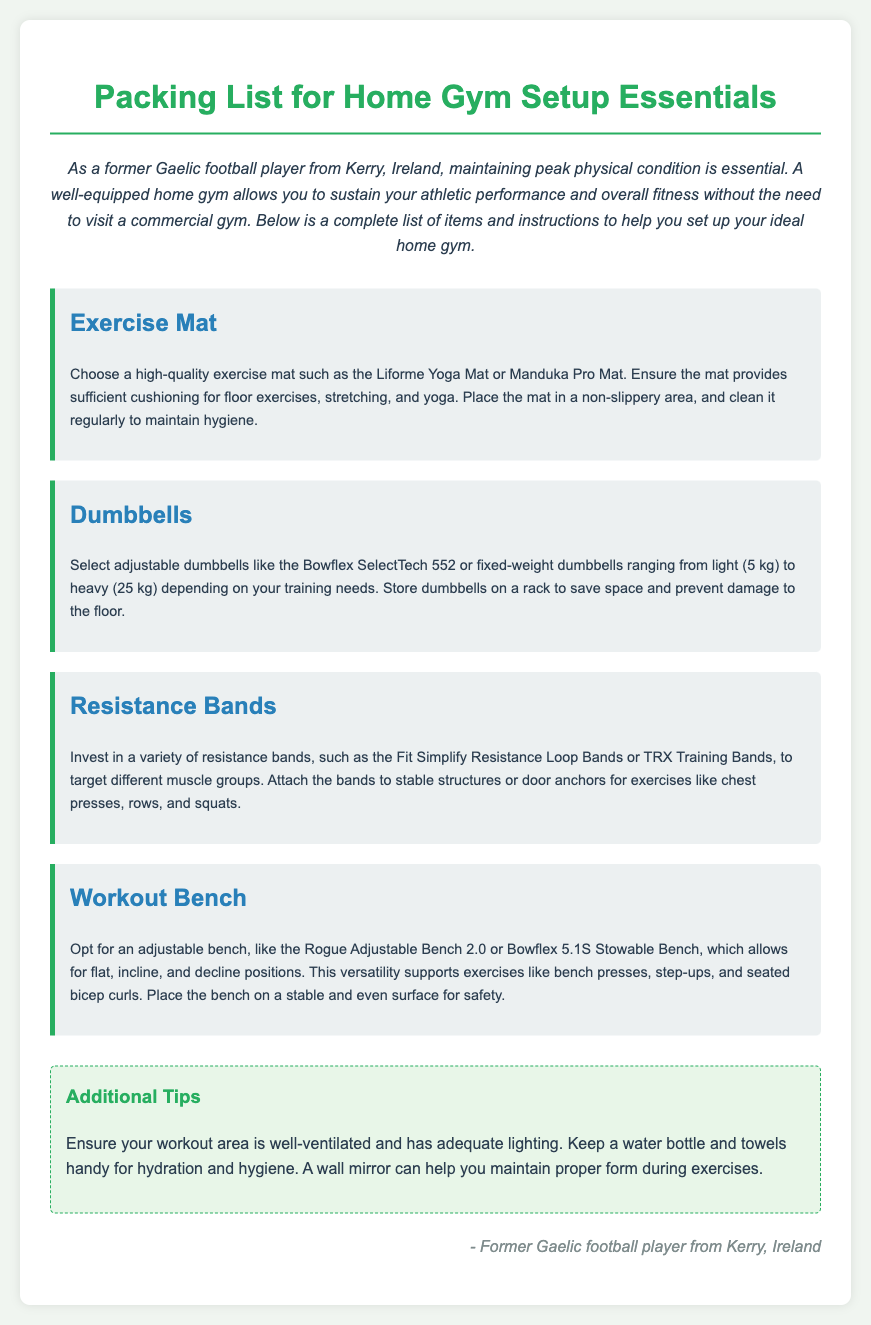What is a recommended exercise mat brand? The document suggests high-quality exercise mats such as the Liforme Yoga Mat or Manduka Pro Mat.
Answer: Liforme Yoga Mat What is the weight range for dumbbells mentioned? The document states that dumbbells should range from light (5 kg) to heavy (25 kg).
Answer: 5 kg to 25 kg What is the purpose of a workout bench? The workout bench is used to support exercises like bench presses, step-ups, and seated bicep curls.
Answer: Support exercises How should resistance bands be attached? The instructions indicate that resistance bands should be attached to stable structures or door anchors.
Answer: Stable structures or door anchors What type of dumbbells does the document suggest? It recommends adjustable dumbbells like Bowflex SelectTech 552 or fixed-weight dumbbells.
Answer: Adjustable dumbbells What is the main focus of the packing list? The packing list is focused on Home Gym Setup Essentials.
Answer: Home Gym Setup Essentials Why is it suggested to keep a water bottle handy? A water bottle is recommended for hydration during workouts.
Answer: Hydration What feature does the adjustable bench provide? The adjustable bench allows for flat, incline, and decline positions.
Answer: Flat, incline, and decline positions What is an important aspect of the workout area? It should be well-ventilated and have adequate lighting.
Answer: Well-ventilated and adequate lighting 